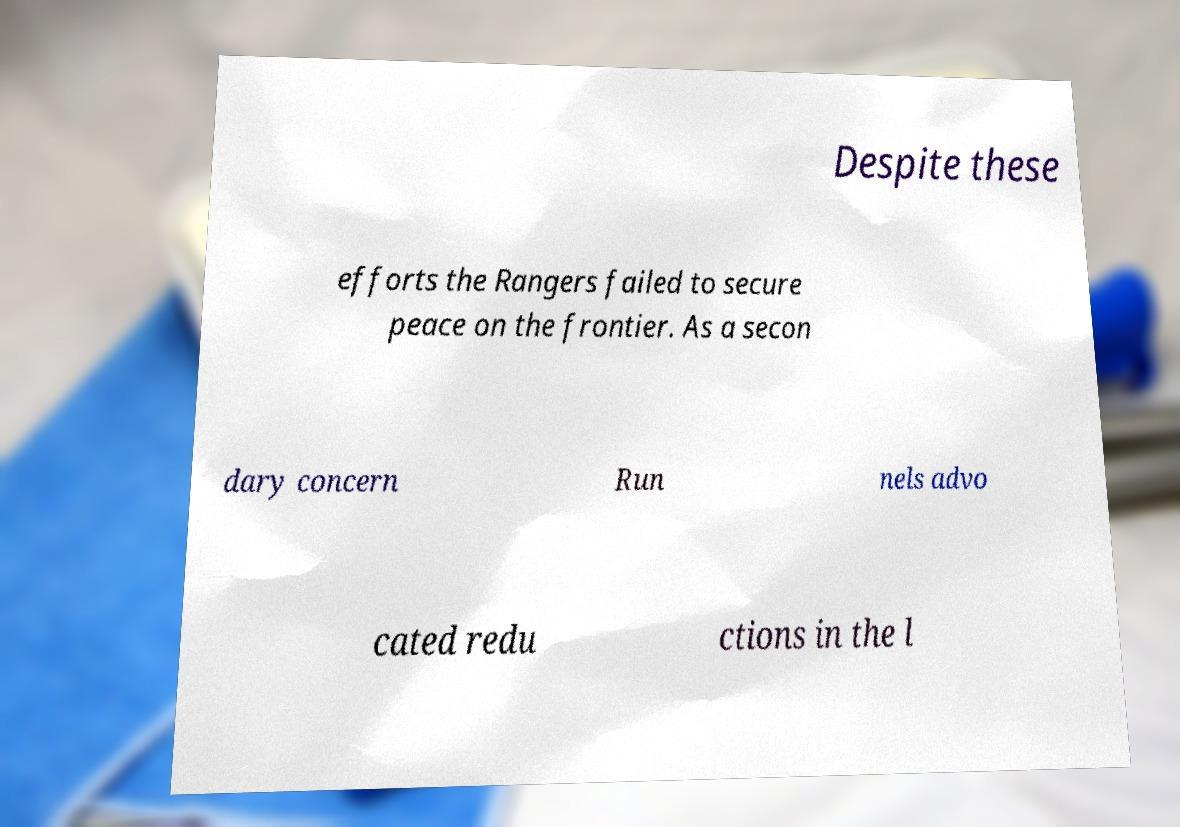Please identify and transcribe the text found in this image. Despite these efforts the Rangers failed to secure peace on the frontier. As a secon dary concern Run nels advo cated redu ctions in the l 